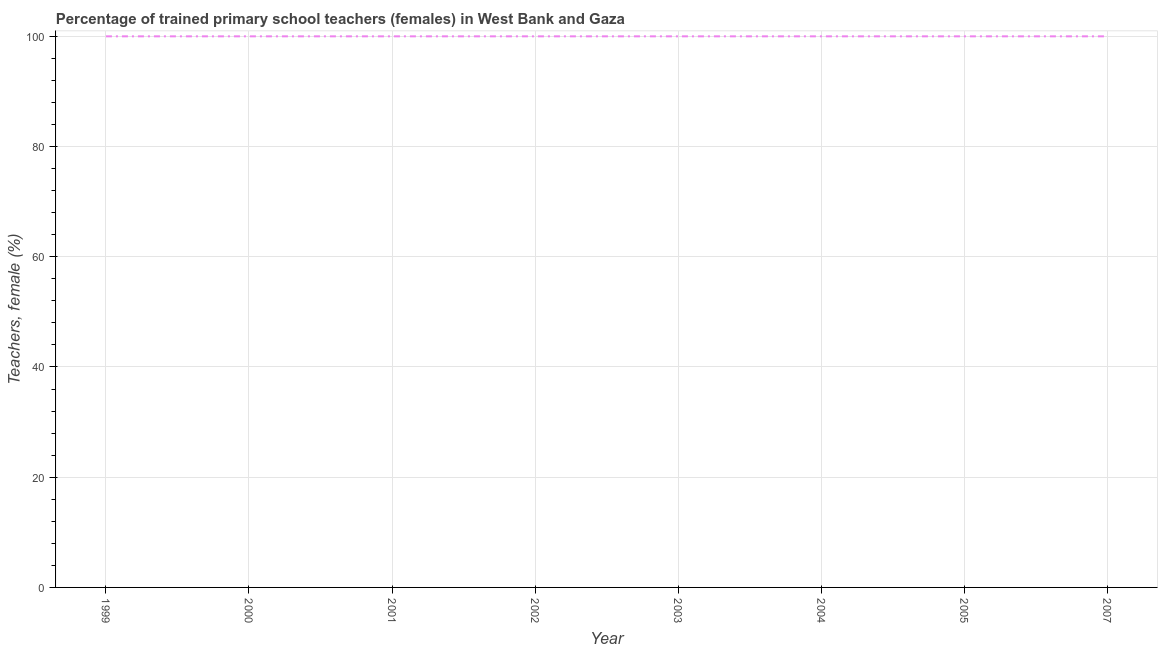What is the percentage of trained female teachers in 2001?
Offer a very short reply. 100. Across all years, what is the maximum percentage of trained female teachers?
Ensure brevity in your answer.  100. Across all years, what is the minimum percentage of trained female teachers?
Make the answer very short. 100. What is the sum of the percentage of trained female teachers?
Your answer should be compact. 800. In how many years, is the percentage of trained female teachers greater than 76 %?
Your answer should be compact. 8. What is the ratio of the percentage of trained female teachers in 1999 to that in 2003?
Provide a succinct answer. 1. Is the percentage of trained female teachers in 1999 less than that in 2004?
Provide a succinct answer. No. Is the sum of the percentage of trained female teachers in 2002 and 2005 greater than the maximum percentage of trained female teachers across all years?
Your answer should be very brief. Yes. What is the difference between the highest and the lowest percentage of trained female teachers?
Your response must be concise. 0. In how many years, is the percentage of trained female teachers greater than the average percentage of trained female teachers taken over all years?
Your answer should be compact. 0. How many years are there in the graph?
Provide a succinct answer. 8. What is the difference between two consecutive major ticks on the Y-axis?
Your answer should be very brief. 20. Are the values on the major ticks of Y-axis written in scientific E-notation?
Give a very brief answer. No. What is the title of the graph?
Keep it short and to the point. Percentage of trained primary school teachers (females) in West Bank and Gaza. What is the label or title of the Y-axis?
Provide a short and direct response. Teachers, female (%). What is the Teachers, female (%) in 1999?
Offer a very short reply. 100. What is the Teachers, female (%) of 2002?
Offer a terse response. 100. What is the Teachers, female (%) in 2005?
Your response must be concise. 100. What is the Teachers, female (%) of 2007?
Make the answer very short. 100. What is the difference between the Teachers, female (%) in 1999 and 2000?
Your answer should be compact. 0. What is the difference between the Teachers, female (%) in 1999 and 2004?
Provide a short and direct response. 0. What is the difference between the Teachers, female (%) in 1999 and 2005?
Offer a very short reply. 0. What is the difference between the Teachers, female (%) in 2000 and 2003?
Keep it short and to the point. 0. What is the difference between the Teachers, female (%) in 2001 and 2007?
Your answer should be compact. 0. What is the difference between the Teachers, female (%) in 2002 and 2003?
Offer a very short reply. 0. What is the difference between the Teachers, female (%) in 2002 and 2007?
Your answer should be compact. 0. What is the difference between the Teachers, female (%) in 2003 and 2004?
Your answer should be very brief. 0. What is the difference between the Teachers, female (%) in 2004 and 2005?
Your answer should be compact. 0. What is the difference between the Teachers, female (%) in 2004 and 2007?
Your response must be concise. 0. What is the ratio of the Teachers, female (%) in 1999 to that in 2000?
Your answer should be compact. 1. What is the ratio of the Teachers, female (%) in 1999 to that in 2001?
Your answer should be very brief. 1. What is the ratio of the Teachers, female (%) in 1999 to that in 2002?
Ensure brevity in your answer.  1. What is the ratio of the Teachers, female (%) in 1999 to that in 2003?
Provide a short and direct response. 1. What is the ratio of the Teachers, female (%) in 1999 to that in 2004?
Offer a very short reply. 1. What is the ratio of the Teachers, female (%) in 1999 to that in 2005?
Make the answer very short. 1. What is the ratio of the Teachers, female (%) in 1999 to that in 2007?
Your response must be concise. 1. What is the ratio of the Teachers, female (%) in 2000 to that in 2001?
Keep it short and to the point. 1. What is the ratio of the Teachers, female (%) in 2000 to that in 2002?
Your answer should be compact. 1. What is the ratio of the Teachers, female (%) in 2000 to that in 2003?
Ensure brevity in your answer.  1. What is the ratio of the Teachers, female (%) in 2000 to that in 2004?
Provide a succinct answer. 1. What is the ratio of the Teachers, female (%) in 2000 to that in 2005?
Your response must be concise. 1. What is the ratio of the Teachers, female (%) in 2001 to that in 2002?
Provide a succinct answer. 1. What is the ratio of the Teachers, female (%) in 2001 to that in 2003?
Give a very brief answer. 1. What is the ratio of the Teachers, female (%) in 2001 to that in 2004?
Your answer should be very brief. 1. What is the ratio of the Teachers, female (%) in 2001 to that in 2005?
Your response must be concise. 1. What is the ratio of the Teachers, female (%) in 2002 to that in 2003?
Provide a short and direct response. 1. What is the ratio of the Teachers, female (%) in 2002 to that in 2007?
Make the answer very short. 1. What is the ratio of the Teachers, female (%) in 2003 to that in 2007?
Provide a succinct answer. 1. What is the ratio of the Teachers, female (%) in 2004 to that in 2005?
Provide a succinct answer. 1. What is the ratio of the Teachers, female (%) in 2005 to that in 2007?
Keep it short and to the point. 1. 